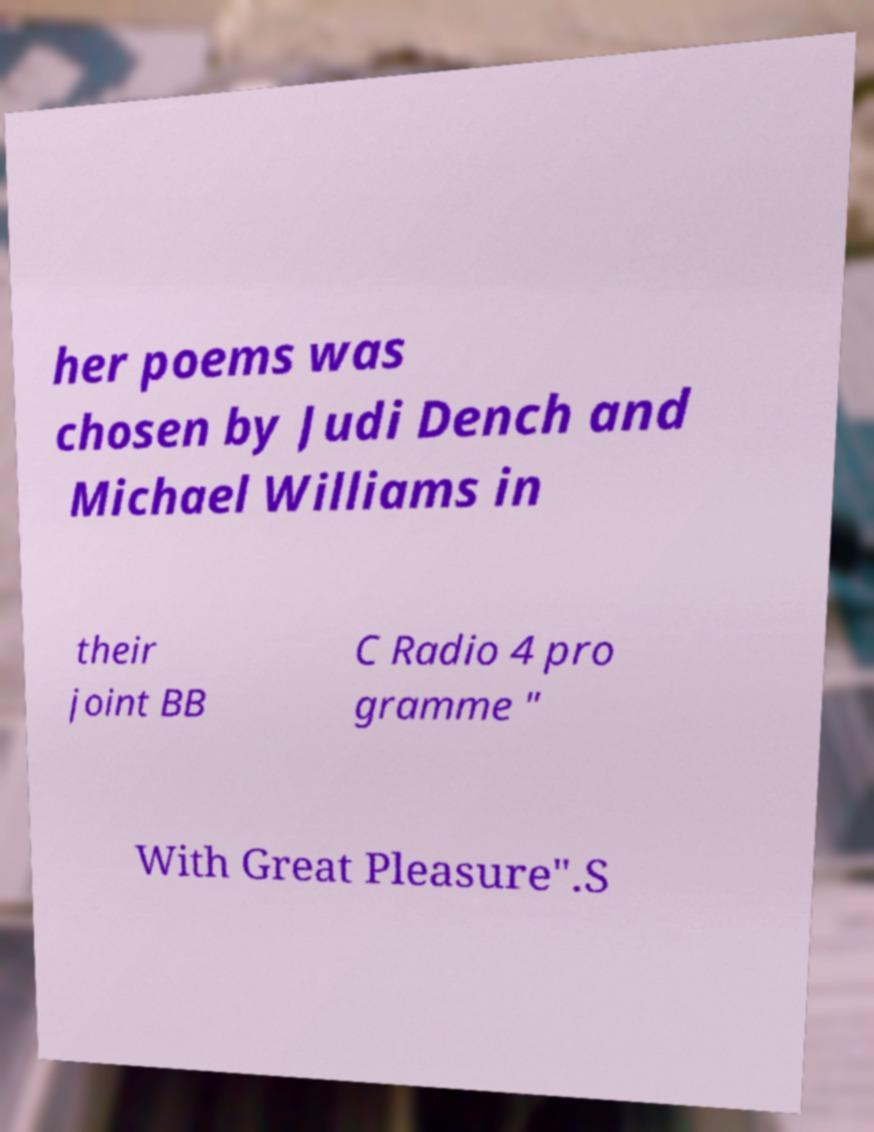There's text embedded in this image that I need extracted. Can you transcribe it verbatim? her poems was chosen by Judi Dench and Michael Williams in their joint BB C Radio 4 pro gramme " With Great Pleasure".S 